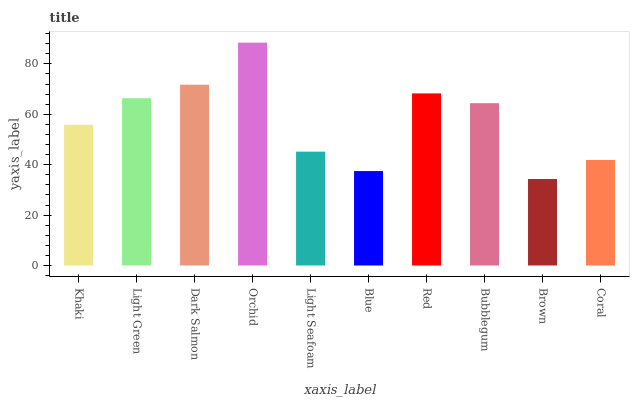Is Light Green the minimum?
Answer yes or no. No. Is Light Green the maximum?
Answer yes or no. No. Is Light Green greater than Khaki?
Answer yes or no. Yes. Is Khaki less than Light Green?
Answer yes or no. Yes. Is Khaki greater than Light Green?
Answer yes or no. No. Is Light Green less than Khaki?
Answer yes or no. No. Is Bubblegum the high median?
Answer yes or no. Yes. Is Khaki the low median?
Answer yes or no. Yes. Is Blue the high median?
Answer yes or no. No. Is Dark Salmon the low median?
Answer yes or no. No. 